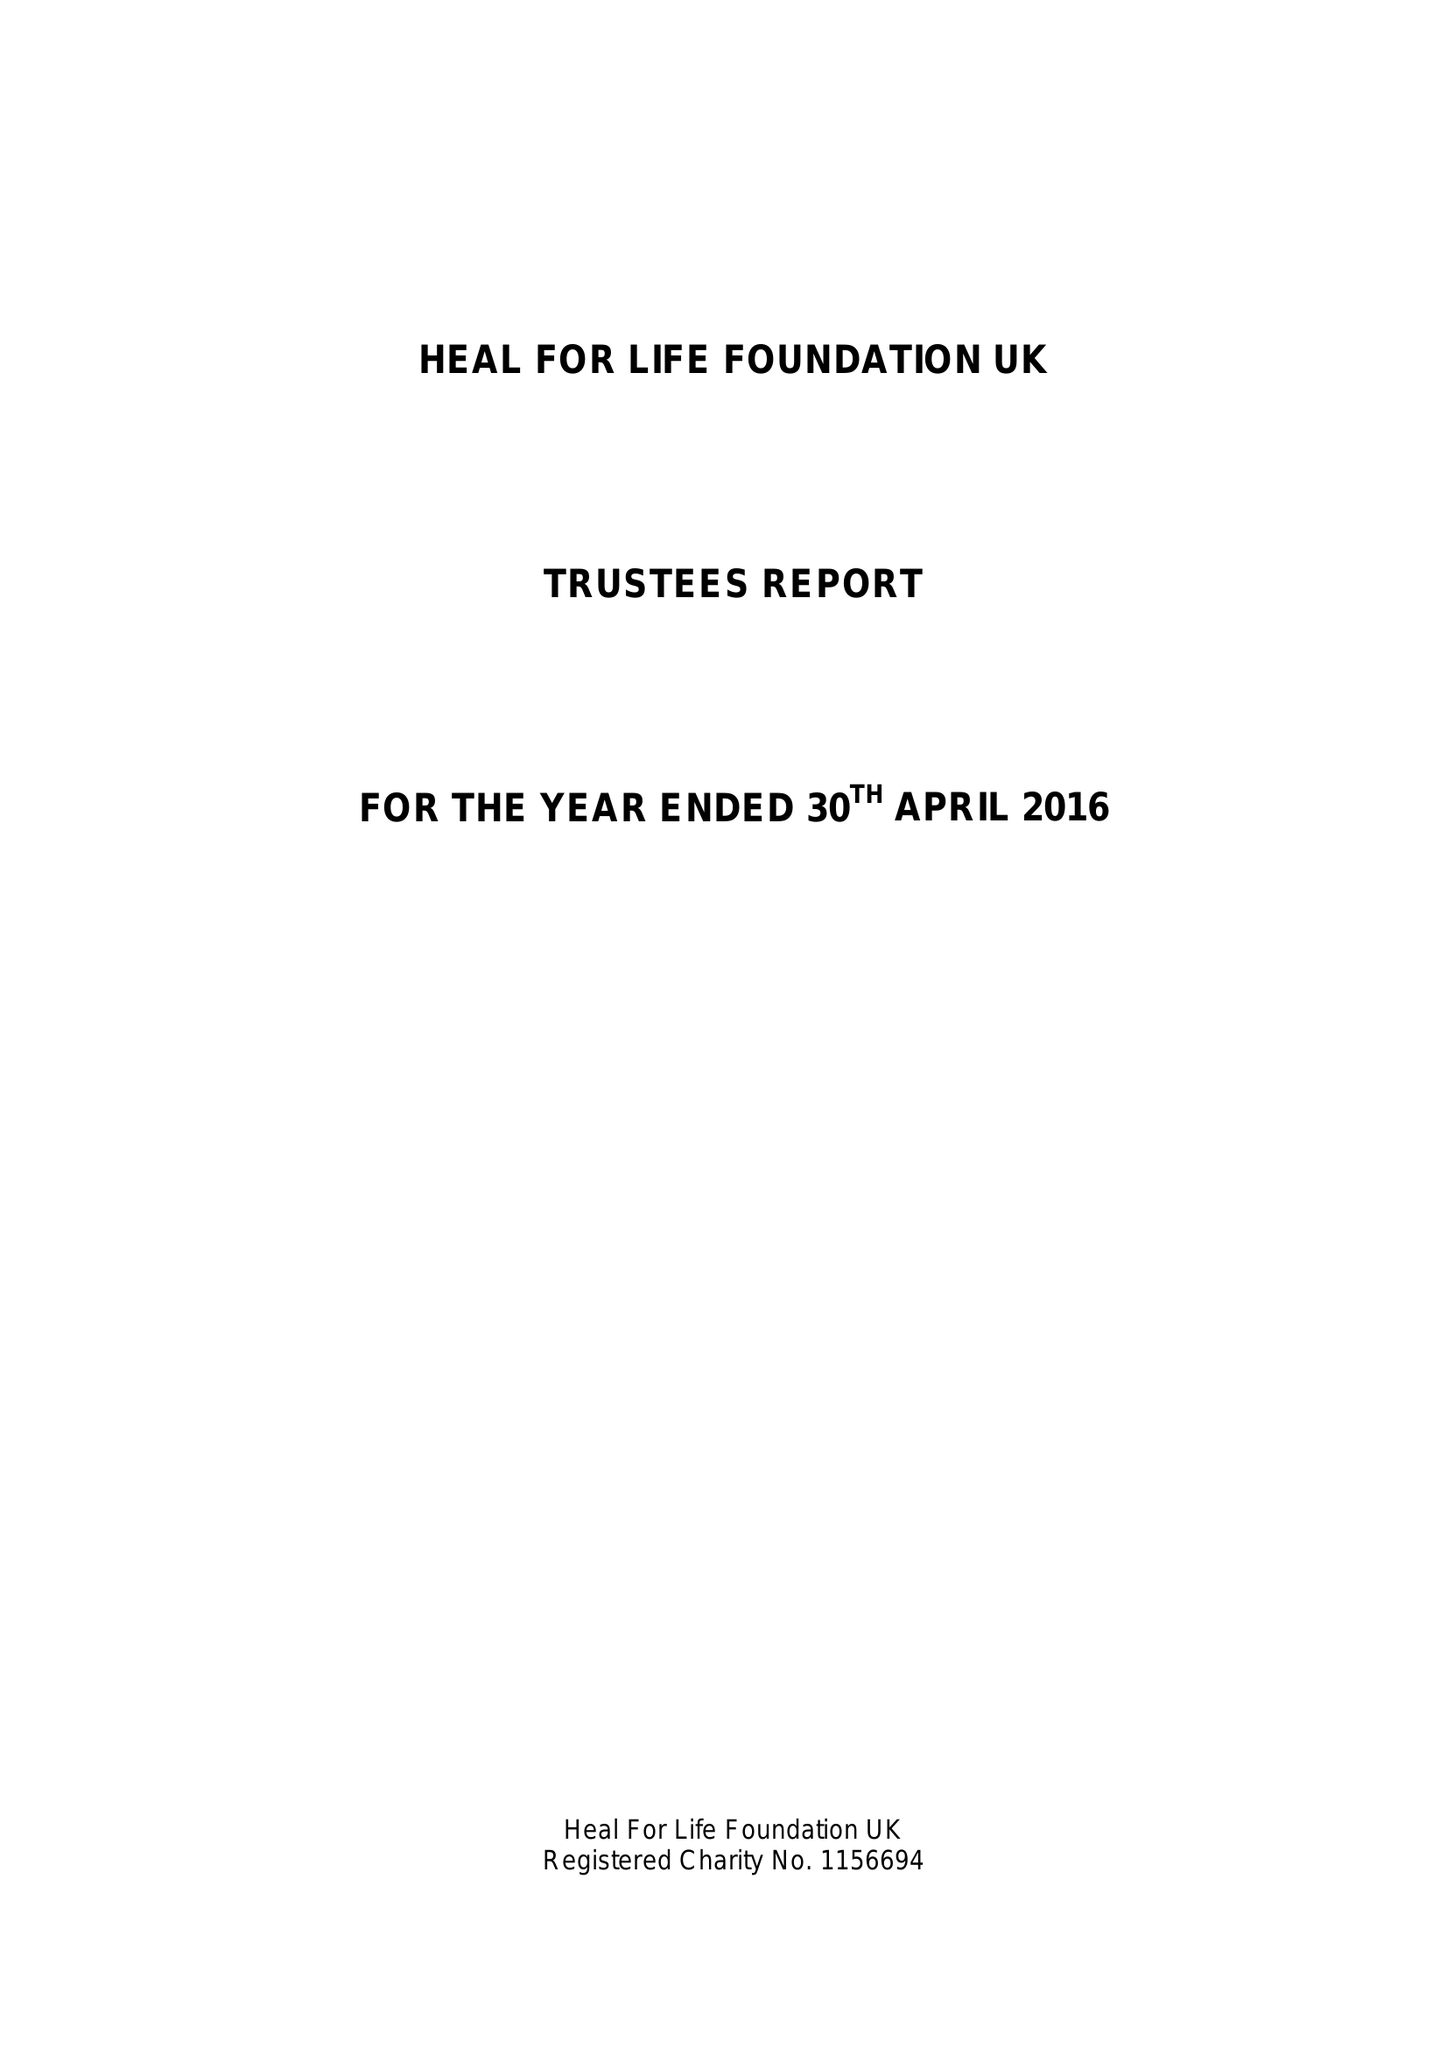What is the value for the address__postcode?
Answer the question using a single word or phrase. TN25 5BJ 